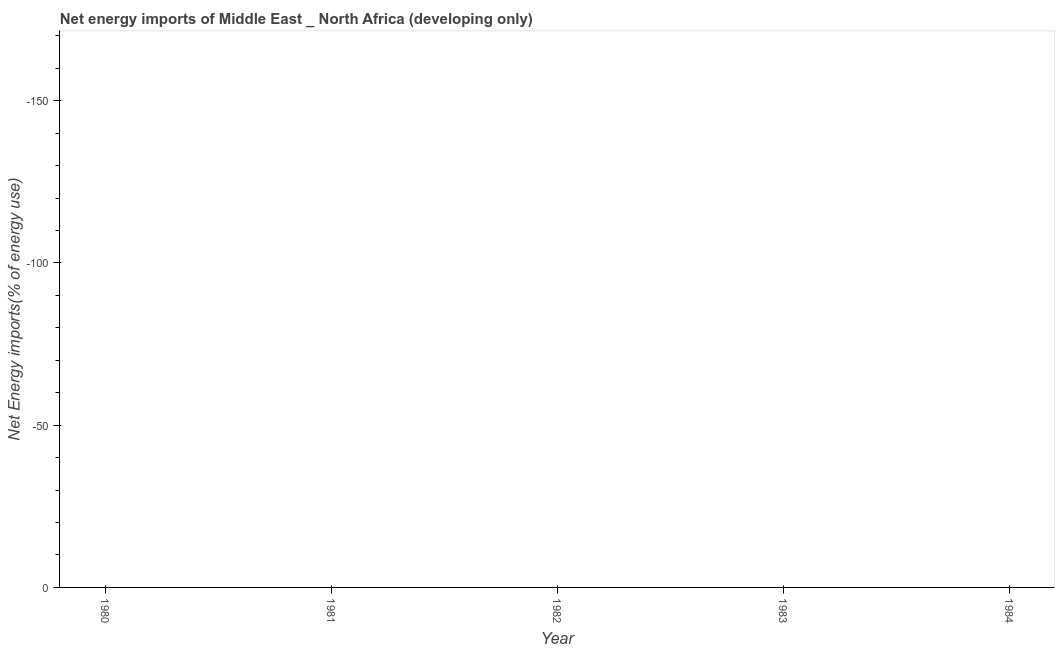What is the energy imports in 1981?
Ensure brevity in your answer.  0. Across all years, what is the minimum energy imports?
Provide a succinct answer. 0. What is the sum of the energy imports?
Give a very brief answer. 0. What is the average energy imports per year?
Offer a terse response. 0. What is the median energy imports?
Make the answer very short. 0. In how many years, is the energy imports greater than the average energy imports taken over all years?
Ensure brevity in your answer.  0. How many years are there in the graph?
Ensure brevity in your answer.  5. Does the graph contain grids?
Your answer should be very brief. No. What is the title of the graph?
Offer a very short reply. Net energy imports of Middle East _ North Africa (developing only). What is the label or title of the Y-axis?
Your answer should be compact. Net Energy imports(% of energy use). What is the Net Energy imports(% of energy use) in 1980?
Give a very brief answer. 0. What is the Net Energy imports(% of energy use) in 1981?
Offer a very short reply. 0. What is the Net Energy imports(% of energy use) of 1983?
Your response must be concise. 0. 